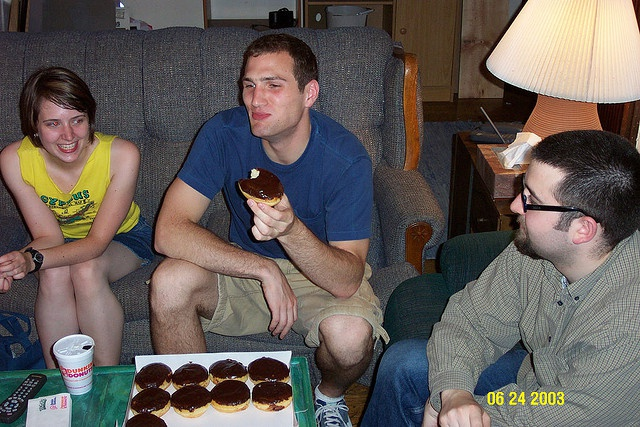Describe the objects in this image and their specific colors. I can see people in black, navy, and gray tones, couch in black, gray, and maroon tones, people in black, gray, darkgray, and pink tones, people in black, gray, and darkgray tones, and couch in black, darkblue, gray, and darkgray tones in this image. 